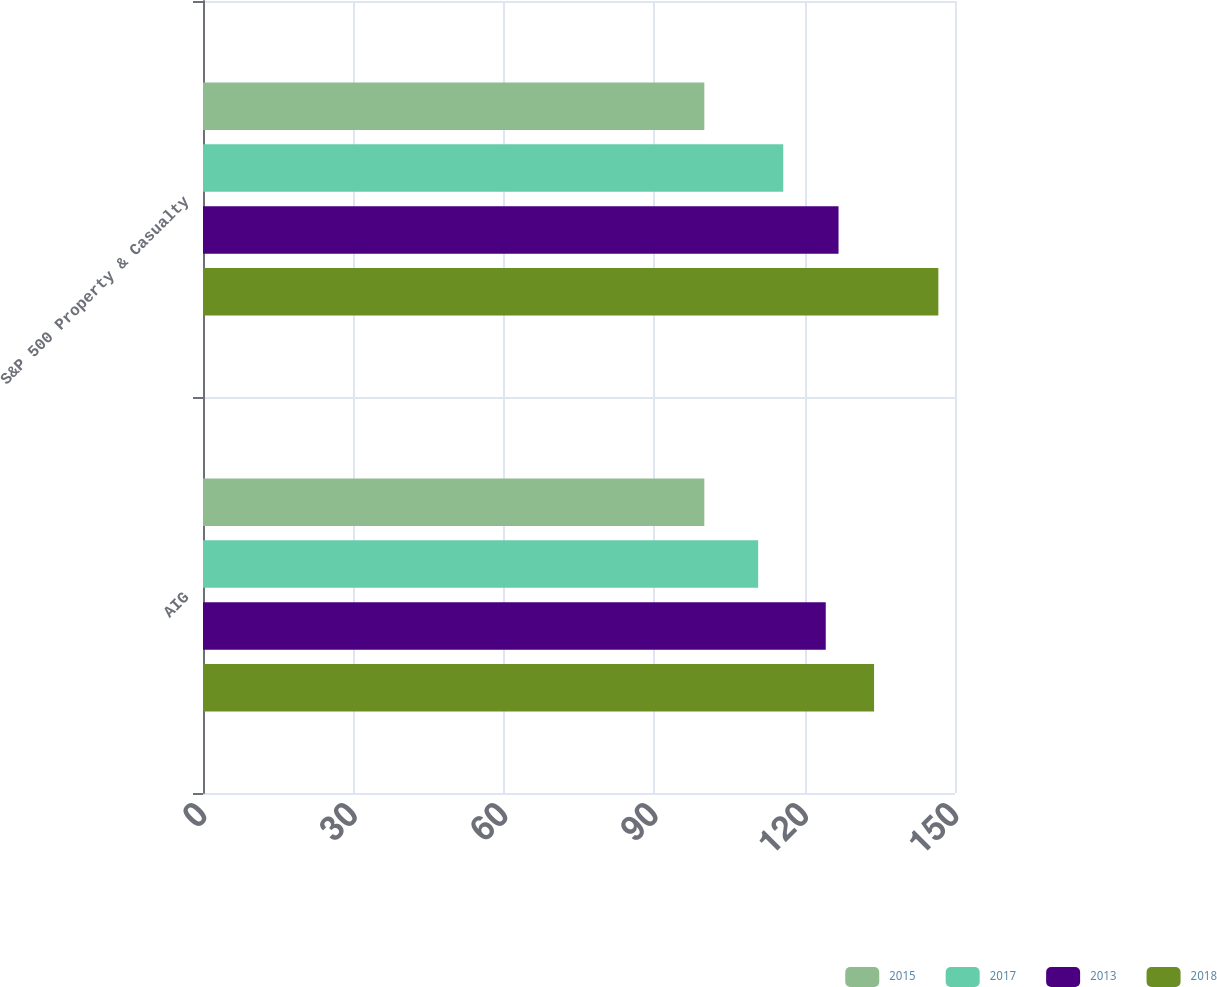Convert chart to OTSL. <chart><loc_0><loc_0><loc_500><loc_500><stacked_bar_chart><ecel><fcel>AIG<fcel>S&P 500 Property & Casualty<nl><fcel>2015<fcel>100<fcel>100<nl><fcel>2017<fcel>110.74<fcel>115.74<nl><fcel>2013<fcel>124.22<fcel>126.77<nl><fcel>2018<fcel>133.86<fcel>146.68<nl></chart> 